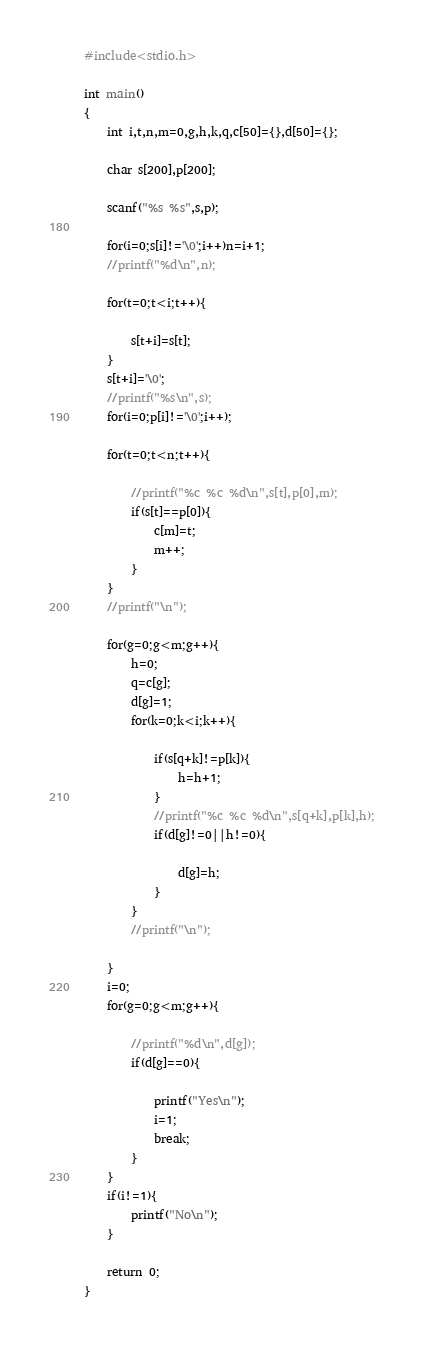<code> <loc_0><loc_0><loc_500><loc_500><_C_>#include<stdio.h>
 
int main()
{
    int i,t,n,m=0,g,h,k,q,c[50]={},d[50]={};
     
    char s[200],p[200];
     
    scanf("%s %s",s,p);
     
    for(i=0;s[i]!='\0';i++)n=i+1;
    //printf("%d\n",n);
     
    for(t=0;t<i;t++){
         
        s[t+i]=s[t];
    }
    s[t+i]='\0';
    //printf("%s\n",s);     
    for(i=0;p[i]!='\0';i++);
     
    for(t=0;t<n;t++){
         
        //printf("%c %c %d\n",s[t],p[0],m);
        if(s[t]==p[0]){
            c[m]=t;
            m++;
        }
    }
    //printf("\n");
     
    for(g=0;g<m;g++){
        h=0;
        q=c[g];
        d[g]=1;
        for(k=0;k<i;k++){
             
            if(s[q+k]!=p[k]){
                h=h+1;
            }
            //printf("%c %c %d\n",s[q+k],p[k],h);
            if(d[g]!=0||h!=0){
                 
                d[g]=h;
            }
        }
        //printf("\n");
         
    }
    i=0;
    for(g=0;g<m;g++){
         
        //printf("%d\n",d[g]);
        if(d[g]==0){
             
            printf("Yes\n");
            i=1;
            break;
        }
    }
    if(i!=1){
        printf("No\n");
    }
     
    return 0;
}
</code> 